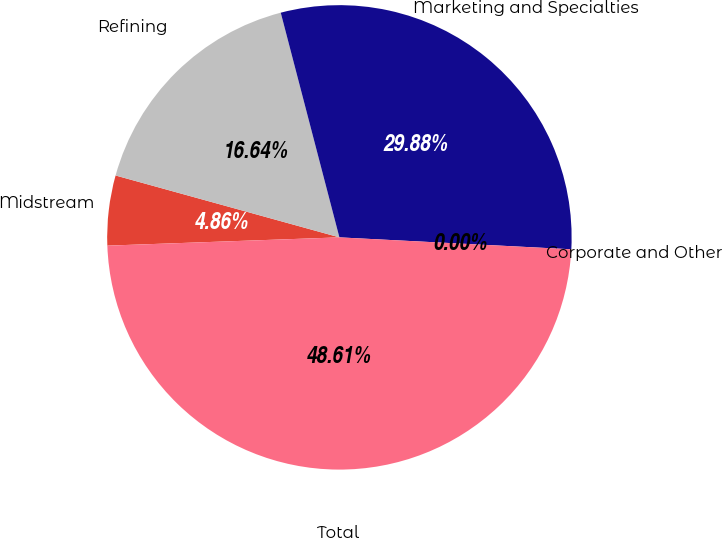Convert chart to OTSL. <chart><loc_0><loc_0><loc_500><loc_500><pie_chart><fcel>Midstream<fcel>Refining<fcel>Marketing and Specialties<fcel>Corporate and Other<fcel>Total<nl><fcel>4.86%<fcel>16.64%<fcel>29.88%<fcel>0.0%<fcel>48.61%<nl></chart> 